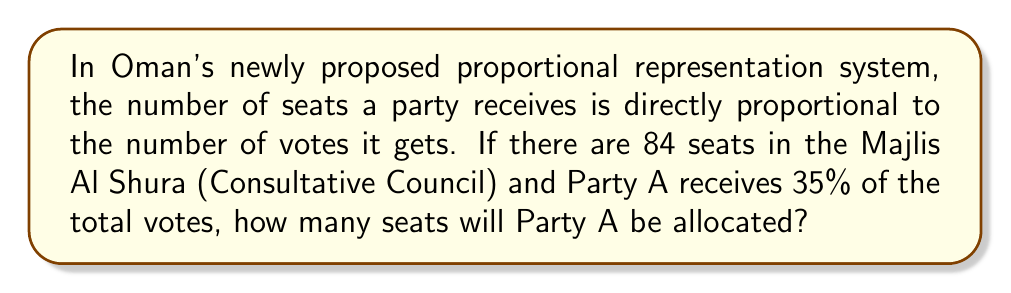Help me with this question. Let's solve this step-by-step:

1) We know that the number of seats a party gets is proportional to the percentage of votes it receives.

2) The total number of seats in the Majlis Al Shura is 84.

3) Party A received 35% of the total votes.

4) To calculate the number of seats, we need to find 35% of 84.

5) We can set up the following equation:
   $x = 84 \times 0.35$

   Where $x$ is the number of seats Party A will receive.

6) Let's solve the equation:
   $x = 84 \times 0.35 = 29.4$

7) Since we can't allocate fractional seats, we need to round to the nearest whole number.

8) Rounding 29.4 to the nearest whole number gives us 29.

Therefore, Party A will be allocated 29 seats in the Majlis Al Shura.
Answer: 29 seats 